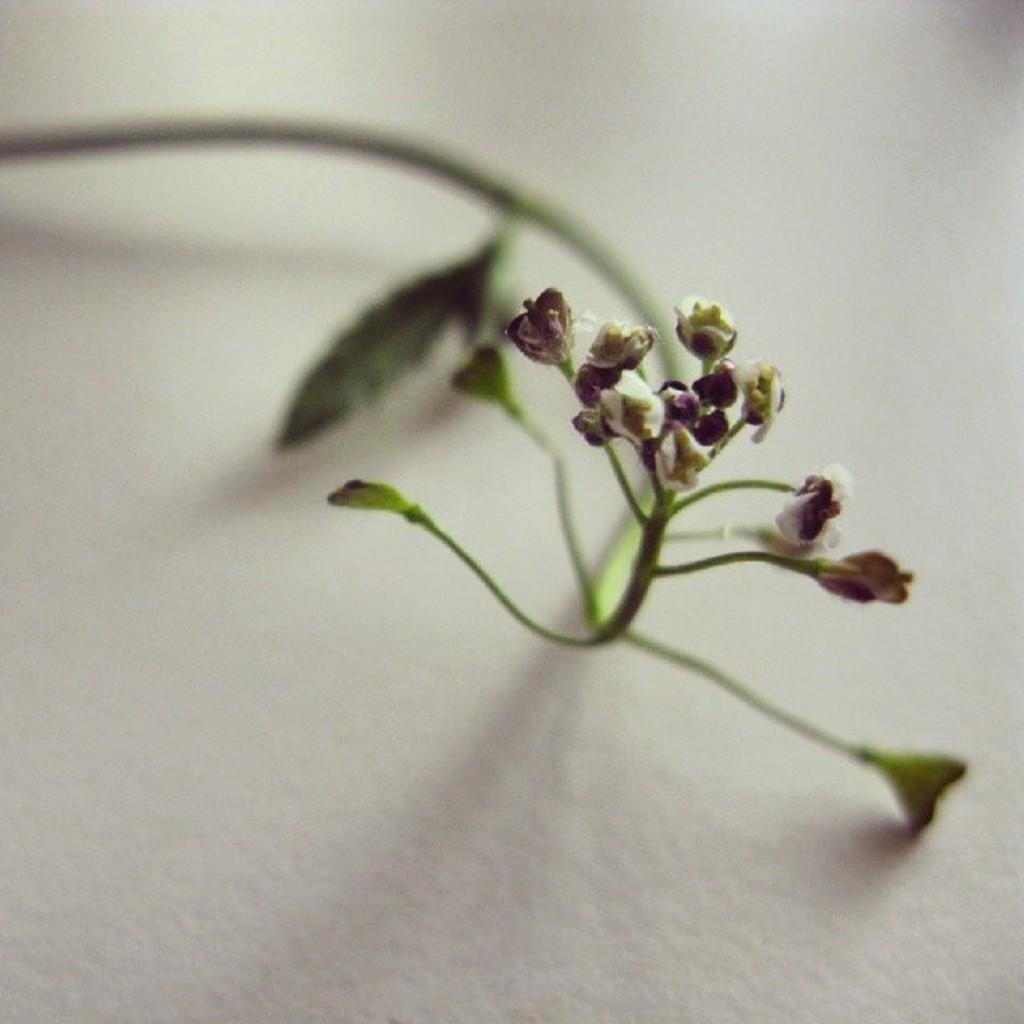What type of plants can be seen in the image? There are flowers in the image. What part of the flowers is visible in the image? There are stems in the image. Where are the flowers and stems located? The flowers and stems are on a wall. What type of territory is being claimed by the flowers in the image? The flowers in the image are not claiming any territory; they are simply growing on a wall. What reward is being given to the flowers in the image? There is no reward being given to the flowers in the image; they are just plants growing on a wall. 